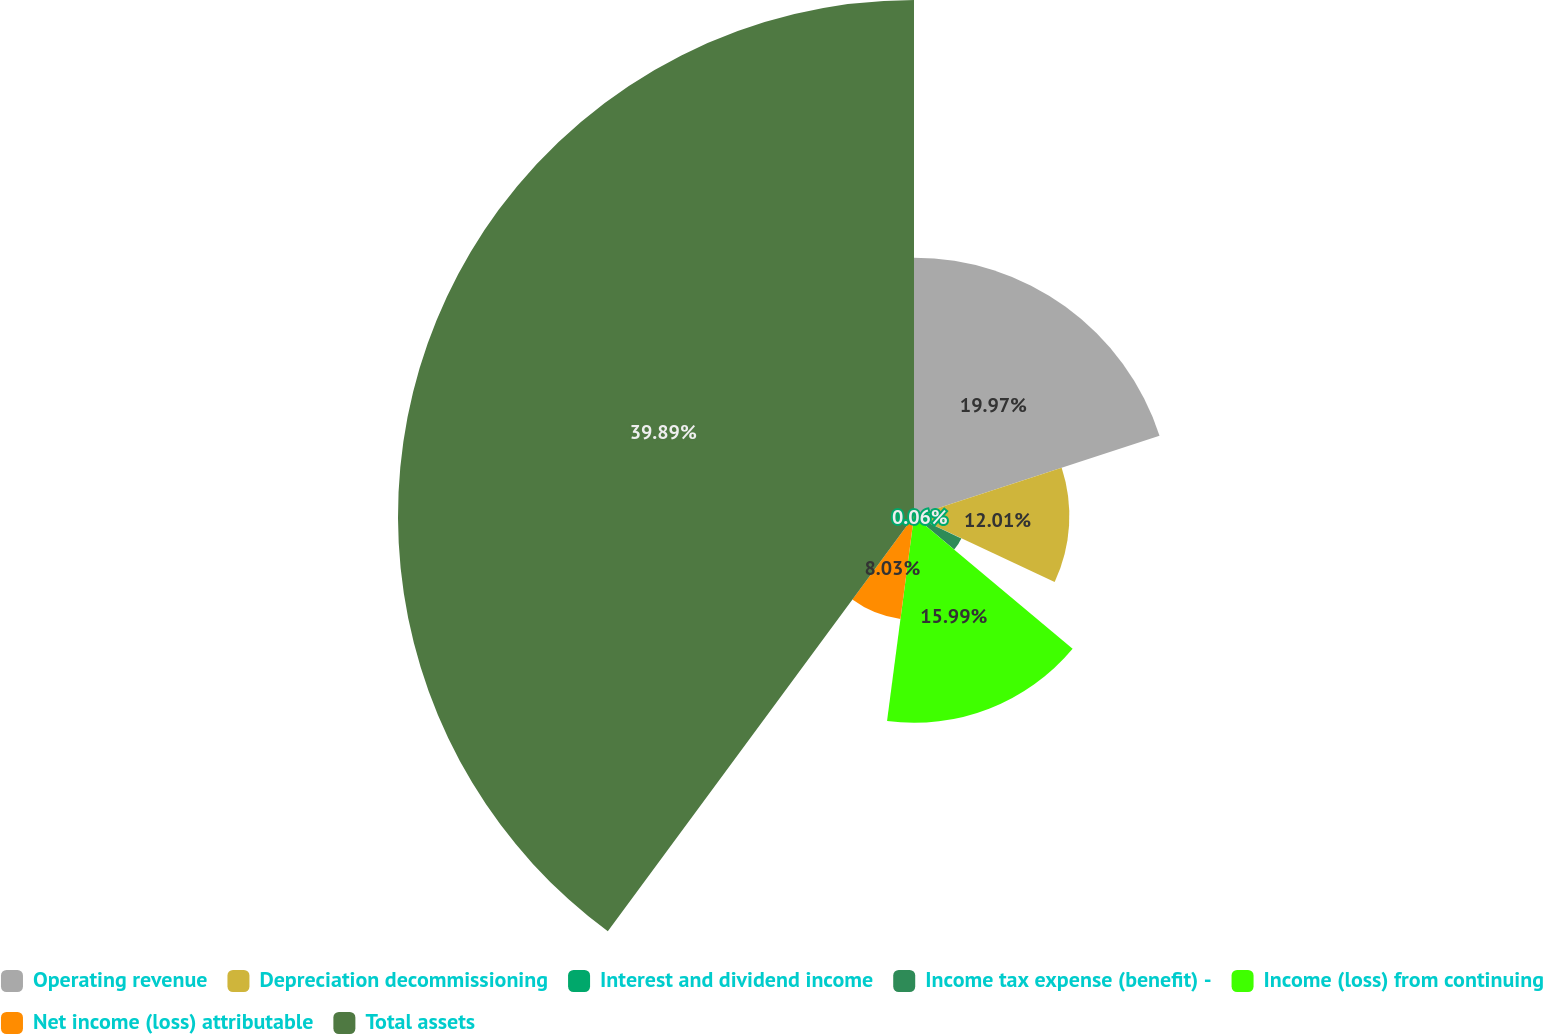<chart> <loc_0><loc_0><loc_500><loc_500><pie_chart><fcel>Operating revenue<fcel>Depreciation decommissioning<fcel>Interest and dividend income<fcel>Income tax expense (benefit) -<fcel>Income (loss) from continuing<fcel>Net income (loss) attributable<fcel>Total assets<nl><fcel>19.97%<fcel>12.01%<fcel>0.06%<fcel>4.05%<fcel>15.99%<fcel>8.03%<fcel>39.89%<nl></chart> 